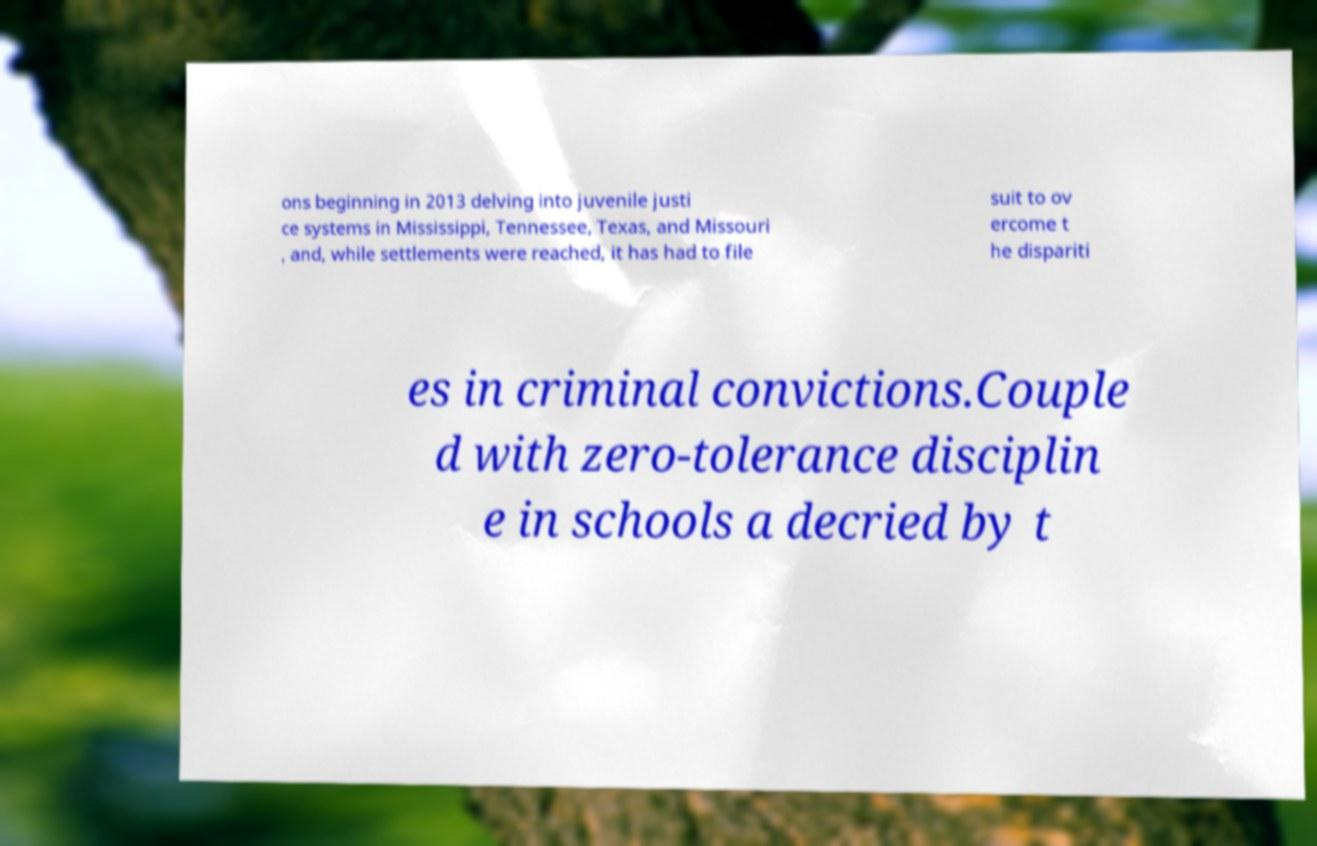Could you assist in decoding the text presented in this image and type it out clearly? ons beginning in 2013 delving into juvenile justi ce systems in Mississippi, Tennessee, Texas, and Missouri , and, while settlements were reached, it has had to file suit to ov ercome t he dispariti es in criminal convictions.Couple d with zero-tolerance disciplin e in schools a decried by t 